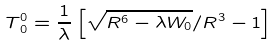<formula> <loc_0><loc_0><loc_500><loc_500>T _ { \, 0 } ^ { 0 } = \frac { 1 } { \lambda } \left [ \sqrt { R ^ { 6 } - \lambda W _ { 0 } } / R ^ { 3 } - 1 \right ]</formula> 